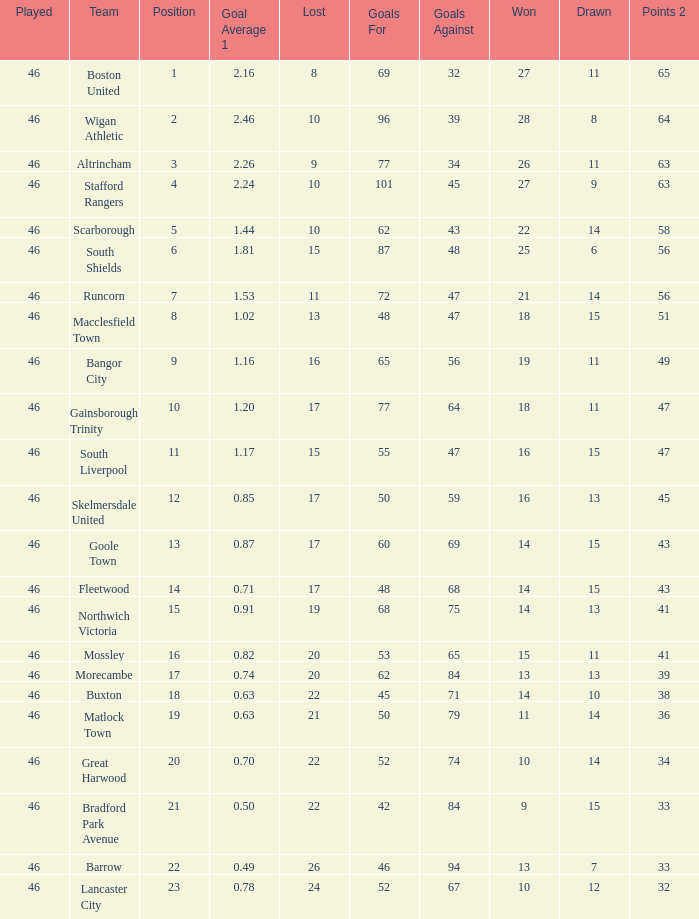How many games did the team who scored 60 goals win? 14.0. 